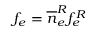Convert formula to latex. <formula><loc_0><loc_0><loc_500><loc_500>f _ { e } = \overline { n } _ { e } ^ { R } f _ { e } ^ { R }</formula> 